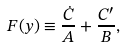<formula> <loc_0><loc_0><loc_500><loc_500>F ( y ) \equiv \frac { \dot { C } } A + { \frac { C ^ { \prime } } B } ,</formula> 